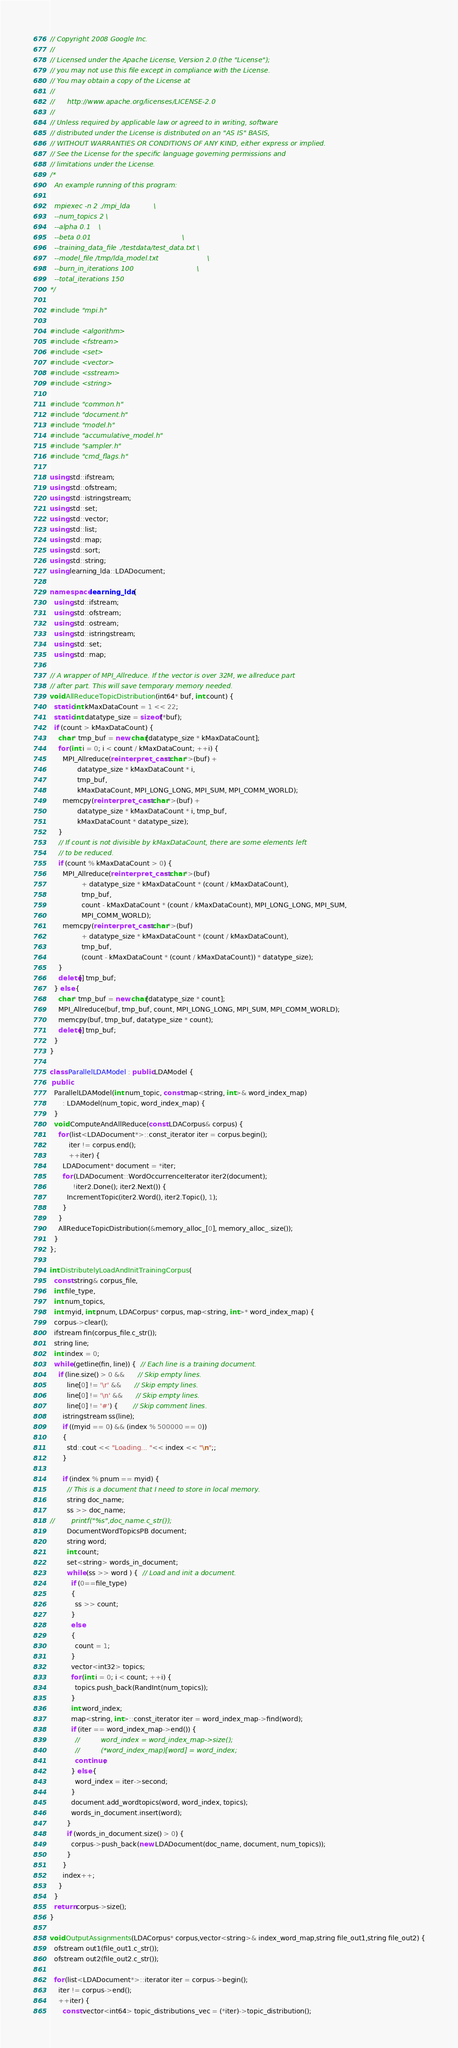Convert code to text. <code><loc_0><loc_0><loc_500><loc_500><_C++_>// Copyright 2008 Google Inc.
//
// Licensed under the Apache License, Version 2.0 (the "License");
// you may not use this file except in compliance with the License.
// You may obtain a copy of the License at
//
//      http://www.apache.org/licenses/LICENSE-2.0
//
// Unless required by applicable law or agreed to in writing, software
// distributed under the License is distributed on an "AS IS" BASIS,
// WITHOUT WARRANTIES OR CONDITIONS OF ANY KIND, either express or implied.
// See the License for the specific language governing permissions and
// limitations under the License.
/*
  An example running of this program:

  mpiexec -n 2 ./mpi_lda           \
  --num_topics 2 \
  --alpha 0.1    \
  --beta 0.01                                           \
  --training_data_file ./testdata/test_data.txt \
  --model_file /tmp/lda_model.txt                       \
  --burn_in_iterations 100                              \
  --total_iterations 150
*/

#include "mpi.h"

#include <algorithm>
#include <fstream>
#include <set>
#include <vector>
#include <sstream>
#include <string>

#include "common.h"
#include "document.h"
#include "model.h"
#include "accumulative_model.h"
#include "sampler.h"
#include "cmd_flags.h"

using std::ifstream;
using std::ofstream;
using std::istringstream;
using std::set;
using std::vector;
using std::list;
using std::map;
using std::sort;
using std::string;
using learning_lda::LDADocument;

namespace learning_lda {
  using std::ifstream;
  using std::ofstream;
  using std::ostream;
  using std::istringstream;
  using std::set;
  using std::map;

// A wrapper of MPI_Allreduce. If the vector is over 32M, we allreduce part
// after part. This will save temporary memory needed.
void AllReduceTopicDistribution(int64* buf, int count) {
  static int kMaxDataCount = 1 << 22;
  static int datatype_size = sizeof(*buf);
  if (count > kMaxDataCount) {
    char* tmp_buf = new char[datatype_size * kMaxDataCount];
    for (int i = 0; i < count / kMaxDataCount; ++i) {
      MPI_Allreduce(reinterpret_cast<char*>(buf) +
             datatype_size * kMaxDataCount * i,
             tmp_buf,
             kMaxDataCount, MPI_LONG_LONG, MPI_SUM, MPI_COMM_WORLD);
      memcpy(reinterpret_cast<char*>(buf) +
             datatype_size * kMaxDataCount * i, tmp_buf,
             kMaxDataCount * datatype_size);
    }
    // If count is not divisible by kMaxDataCount, there are some elements left
    // to be reduced.
    if (count % kMaxDataCount > 0) {
      MPI_Allreduce(reinterpret_cast<char*>(buf)
               + datatype_size * kMaxDataCount * (count / kMaxDataCount),
               tmp_buf,
               count - kMaxDataCount * (count / kMaxDataCount), MPI_LONG_LONG, MPI_SUM,
               MPI_COMM_WORLD);
      memcpy(reinterpret_cast<char*>(buf)
               + datatype_size * kMaxDataCount * (count / kMaxDataCount),
               tmp_buf,
               (count - kMaxDataCount * (count / kMaxDataCount)) * datatype_size);
    }
    delete[] tmp_buf;
  } else {
    char* tmp_buf = new char[datatype_size * count];
    MPI_Allreduce(buf, tmp_buf, count, MPI_LONG_LONG, MPI_SUM, MPI_COMM_WORLD);
    memcpy(buf, tmp_buf, datatype_size * count);
    delete[] tmp_buf;
  }
}

class ParallelLDAModel : public LDAModel {
 public:
  ParallelLDAModel(int num_topic, const map<string, int>& word_index_map)
      : LDAModel(num_topic, word_index_map) {
  }
  void ComputeAndAllReduce(const LDACorpus& corpus) {
    for (list<LDADocument*>::const_iterator iter = corpus.begin();
         iter != corpus.end();
         ++iter) {
      LDADocument* document = *iter;
      for (LDADocument::WordOccurrenceIterator iter2(document);
           !iter2.Done(); iter2.Next()) {
        IncrementTopic(iter2.Word(), iter2.Topic(), 1);
      }
    }
    AllReduceTopicDistribution(&memory_alloc_[0], memory_alloc_.size());
  }
};

int DistributelyLoadAndInitTrainingCorpus(
  const string& corpus_file,
  int file_type,
  int num_topics,
  int myid, int pnum, LDACorpus* corpus, map<string, int>* word_index_map) {
  corpus->clear();
  ifstream fin(corpus_file.c_str());
  string line;
  int index = 0;
  while (getline(fin, line)) {  // Each line is a training document.
    if (line.size() > 0 &&      // Skip empty lines.
        line[0] != '\r' &&      // Skip empty lines.
        line[0] != '\n' &&      // Skip empty lines.
        line[0] != '#') {       // Skip comment lines.
      istringstream ss(line);
      if ((myid == 0) && (index % 500000 == 0))
      {
        std::cout << "Loading... "<< index << "\n";;
      }
      
      if (index % pnum == myid) {
        // This is a document that I need to store in local memory.
        string doc_name;
        ss >> doc_name;
//        printf("%s",doc_name.c_str());        
        DocumentWordTopicsPB document;
        string word;
        int count;
        set<string> words_in_document;
        while (ss >> word ) {  // Load and init a document.
          if (0==file_type)
          {
            ss >> count;
          }
          else
          {
            count = 1;
          }
          vector<int32> topics;
          for (int i = 0; i < count; ++i) {
            topics.push_back(RandInt(num_topics));
          }
          int word_index;
          map<string, int>::const_iterator iter = word_index_map->find(word);
          if (iter == word_index_map->end()) {
            //          word_index = word_index_map->size();
            //          (*word_index_map)[word] = word_index;
            continue;
          } else {
            word_index = iter->second;
          }
          document.add_wordtopics(word, word_index, topics);
          words_in_document.insert(word);
        }
        if (words_in_document.size() > 0) {
          corpus->push_back(new LDADocument(doc_name, document, num_topics));
        }
      }
      index++;
    }
  }
  return corpus->size();
}

void OutputAssignments(LDACorpus* corpus,vector<string>& index_word_map,string file_out1,string file_out2) {
  ofstream out1(file_out1.c_str());
  ofstream out2(file_out2.c_str());

  for (list<LDADocument*>::iterator iter = corpus->begin();
    iter != corpus->end();
    ++iter) {
      const vector<int64> topic_distributions_vec = (*iter)->topic_distribution();</code> 